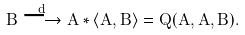Convert formula to latex. <formula><loc_0><loc_0><loc_500><loc_500>B \overset { d } { \longrightarrow } A \ast \left \langle A , B \right \rangle = Q ( A , A , B ) .</formula> 